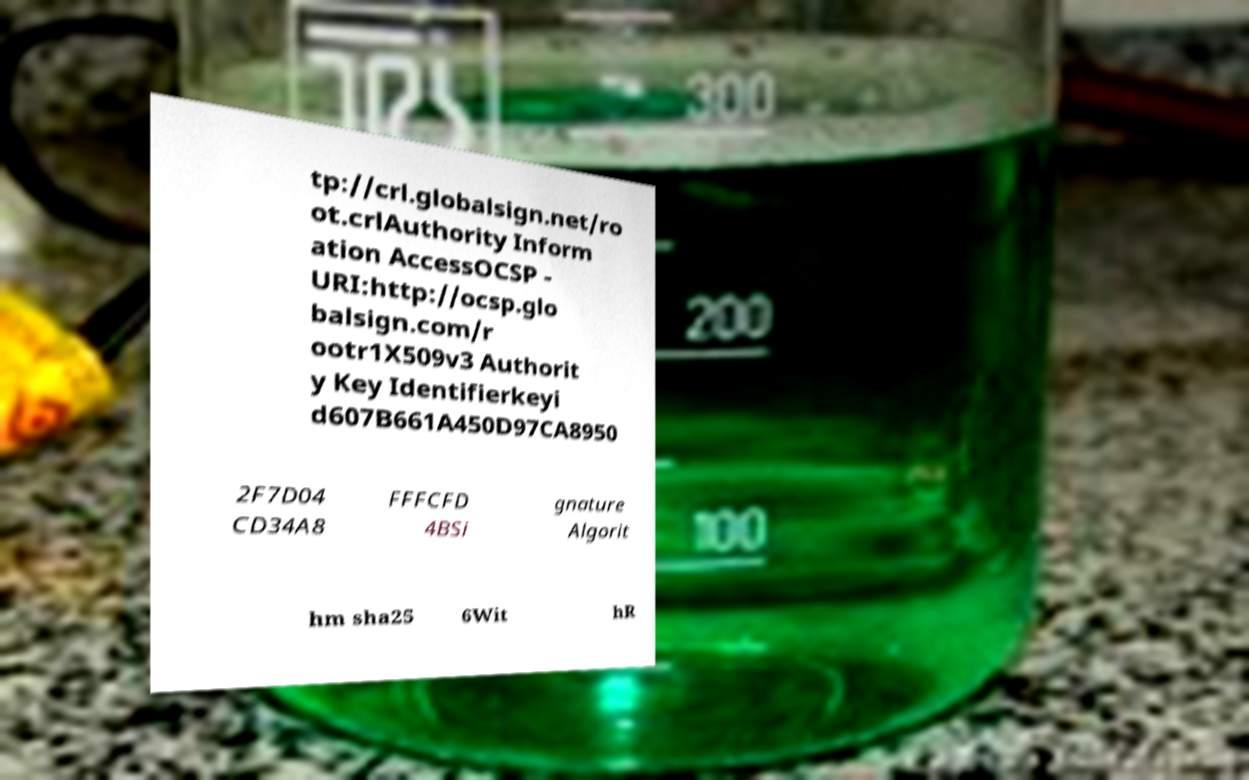I need the written content from this picture converted into text. Can you do that? tp://crl.globalsign.net/ro ot.crlAuthority Inform ation AccessOCSP - URI:http://ocsp.glo balsign.com/r ootr1X509v3 Authorit y Key Identifierkeyi d607B661A450D97CA8950 2F7D04 CD34A8 FFFCFD 4BSi gnature Algorit hm sha25 6Wit hR 